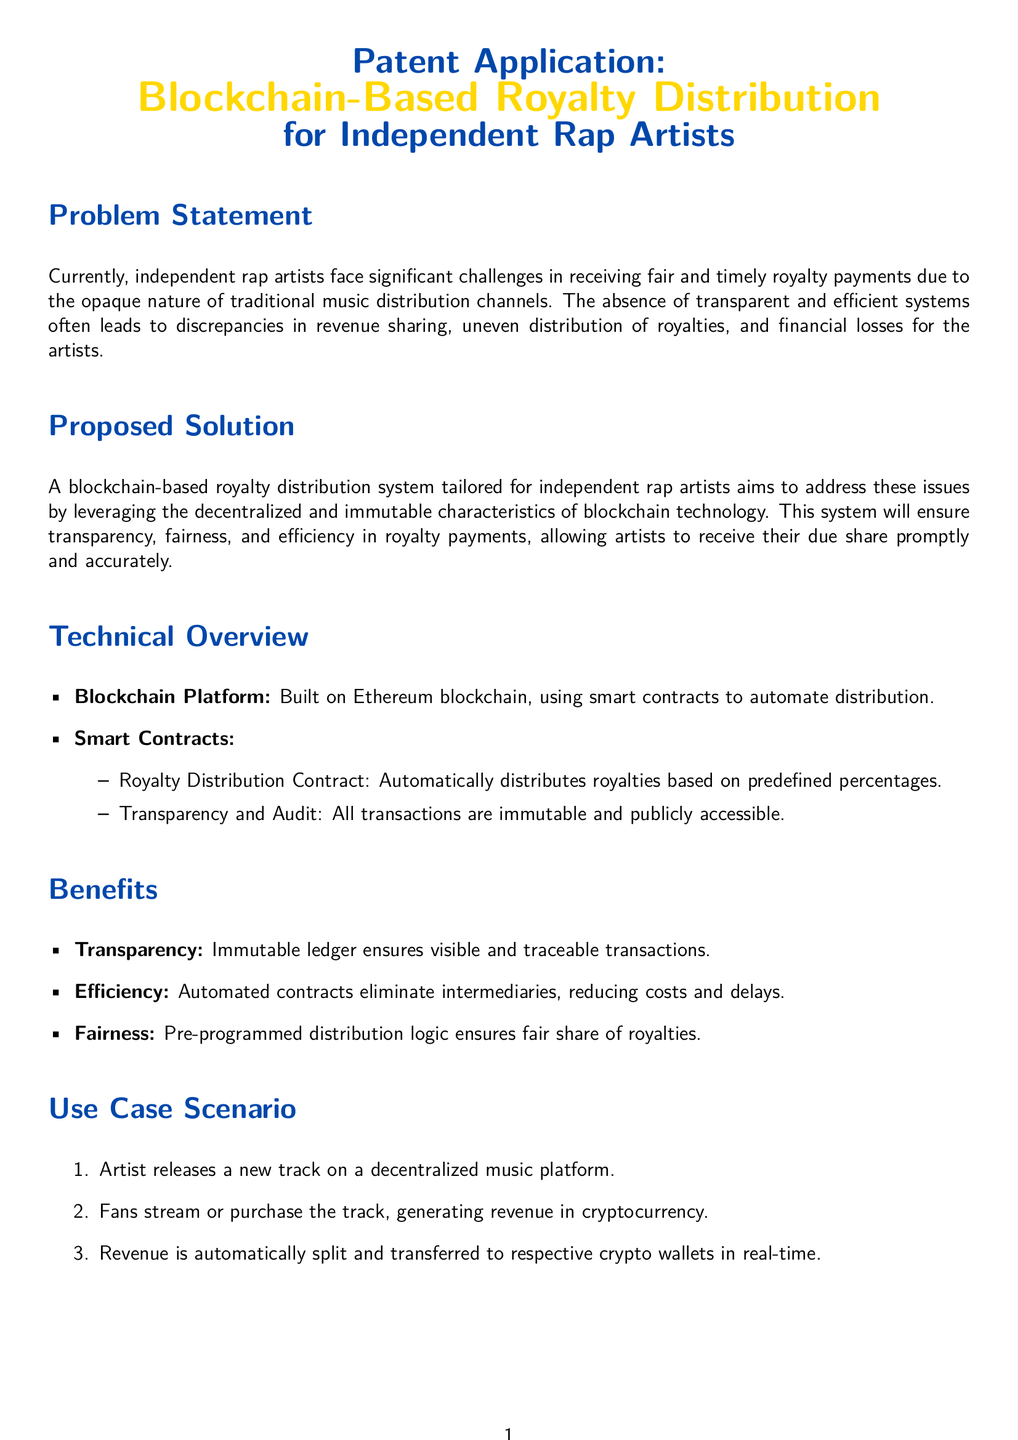What are the challenges faced by independent rap artists? The document states that the challenges include significant difficulties in receiving fair and timely royalty payments due to opaque traditional distribution channels.
Answer: Opaque distribution channels What technology is the proposed royalty distribution system based on? The proposed system utilizes blockchain technology, specifically built on the Ethereum blockchain.
Answer: Ethereum blockchain What is the purpose of smart contracts in this context? Smart contracts are used to automate the distribution of royalties based on predefined percentages.
Answer: Automate distribution What is one benefit of using a blockchain system for royalty distribution? One benefit mentioned is transparency, as the immutable ledger ensures visible and traceable transactions.
Answer: Transparency What is the first step in the use case scenario? The first step in the use case scenario involves the artist releasing a new track on a decentralized music platform.
Answer: Artist releasing a new track Who are some of the entities involved in the proposed system? The document lists independent artists, producers, and music platforms as the entities involved.
Answer: Independent artists, producers, music platforms What does the term "immutable" refer to in the context of this application? "Immutable" refers to the characteristic of blockchain technology where transactions cannot be altered or deleted, ensuring integrity.
Answer: Cannot be altered What is the primary goal of the proposed solution? The primary goal of the proposed solution is to ensure transparency, fairness, and efficiency in royalty payments for artists.
Answer: Ensure transparency and fairness What example artist is mentioned in the entities involved section? The document provides Kendrick Lamar as an example of an independent artist involved in the system.
Answer: Kendrick Lamar 